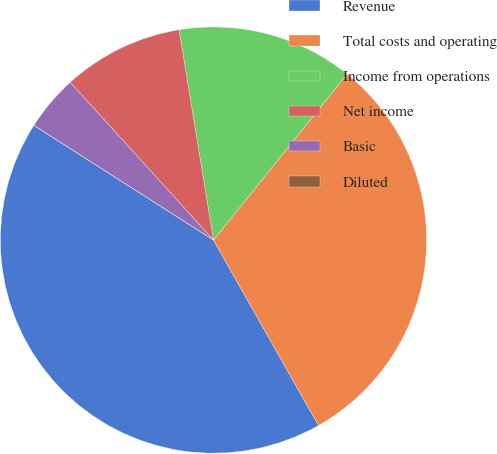Convert chart. <chart><loc_0><loc_0><loc_500><loc_500><pie_chart><fcel>Revenue<fcel>Total costs and operating<fcel>Income from operations<fcel>Net income<fcel>Basic<fcel>Diluted<nl><fcel>42.25%<fcel>31.01%<fcel>13.37%<fcel>9.15%<fcel>4.22%<fcel>0.0%<nl></chart> 